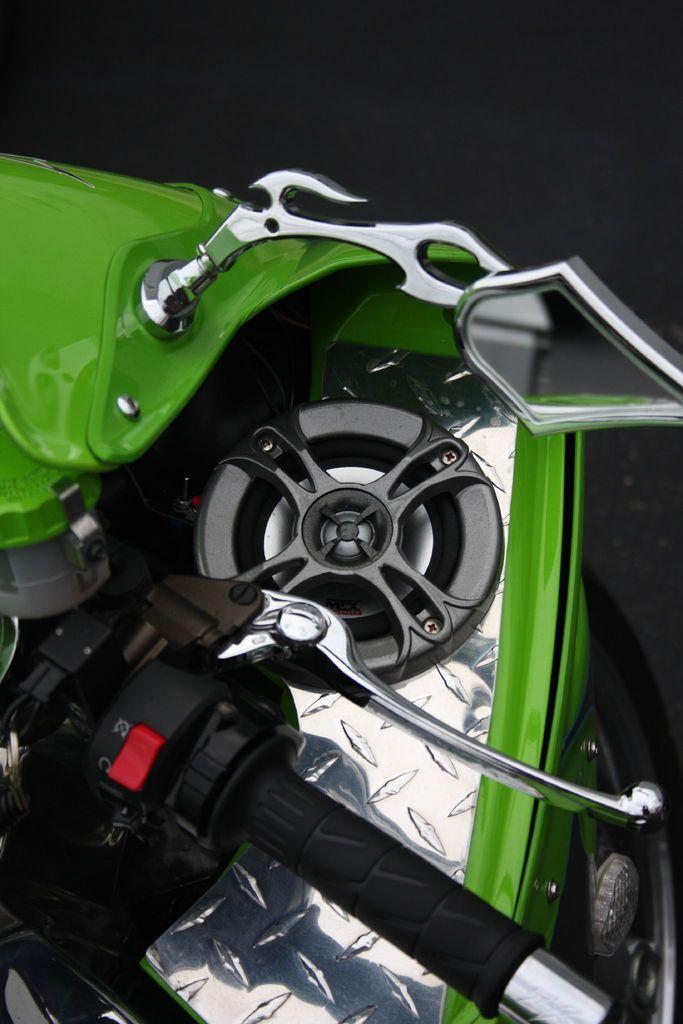What color is the vehicle in the image? The vehicle in the image is green. What feature does the vehicle have for holding or carrying? The vehicle has a handle. What feature does the vehicle have for observing surroundings? The vehicle has a mirror. What type of smell can be detected from the vehicle in the image? There is no information about the smell of the vehicle in the image, as it only provides visual details. 